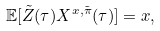<formula> <loc_0><loc_0><loc_500><loc_500>\mathbb { E } [ \tilde { Z } ( \tau ) X ^ { x , \tilde { \pi } } ( \tau ) ] = x ,</formula> 